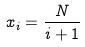<formula> <loc_0><loc_0><loc_500><loc_500>x _ { i } = \frac { N } { i + 1 }</formula> 